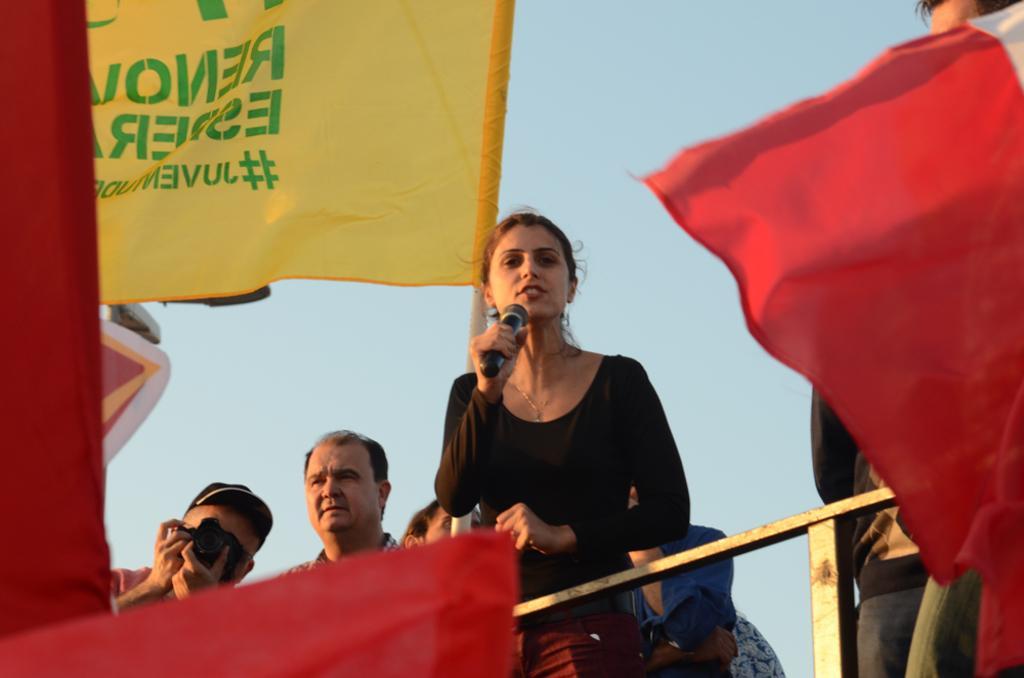Could you give a brief overview of what you see in this image? In the middle of the picture, we see the woman in the black dress is holding the microphone and she is talking on the microphone. Behind her, we see many people are standing. In front of them, we see the railing. On the right side, we see a flag in red and white color. The man on the left side is clicking photos with the camera. On the left side, we see the flags in red and yellow color. In the background, we see the sky. 